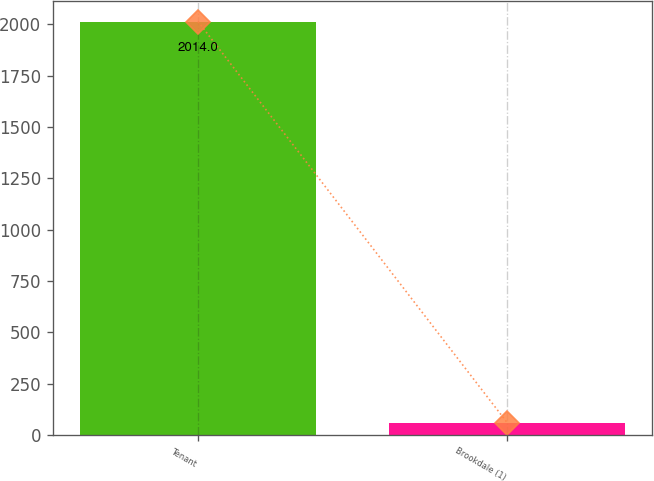<chart> <loc_0><loc_0><loc_500><loc_500><bar_chart><fcel>Tenant<fcel>Brookdale (1)<nl><fcel>2014<fcel>59<nl></chart> 